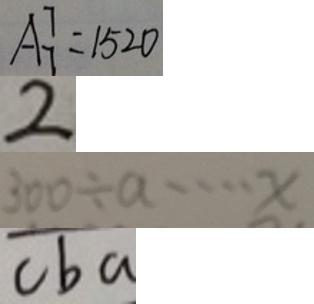<formula> <loc_0><loc_0><loc_500><loc_500>A ^ { 7 } _ { 7 } = 1 5 2 0 
 2 
 3 0 0 \div a \cdots x 
 c b a</formula> 